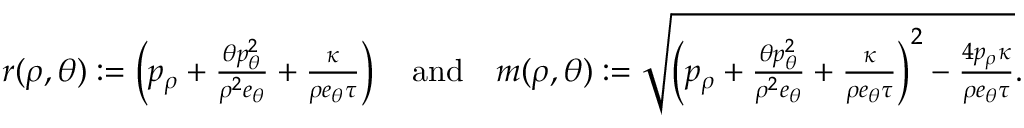<formula> <loc_0><loc_0><loc_500><loc_500>\begin{array} { r } { r ( \rho , \theta ) \colon = \left ( p _ { \rho } + \frac { \theta p _ { \theta } ^ { 2 } } { \rho ^ { 2 } e _ { \theta } } + \frac { \kappa } { \rho e _ { \theta } \tau } \right ) \quad a n d \quad m ( \rho , \theta ) \colon = \sqrt { \left ( p _ { \rho } + \frac { \theta p _ { \theta } ^ { 2 } } { \rho ^ { 2 } e _ { \theta } } + \frac { \kappa } { \rho e _ { \theta } \tau } \right ) ^ { 2 } - \frac { 4 p _ { \rho } \kappa } { \rho e _ { \theta } \tau } } . } \end{array}</formula> 